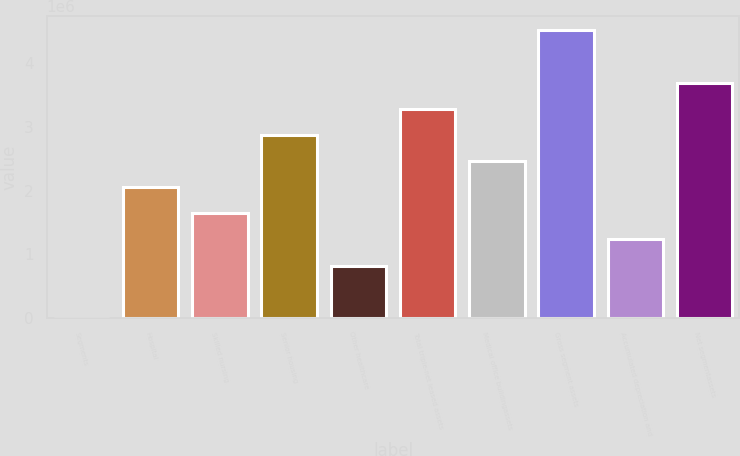Convert chart to OTSL. <chart><loc_0><loc_0><loc_500><loc_500><bar_chart><fcel>Segments<fcel>Hospital<fcel>Skilled nursing<fcel>Senior housing<fcel>Other healthcare<fcel>Total triple-net leased assets<fcel>Medical office buildingassets<fcel>Gross segment assets<fcel>Accumulated depreciation and<fcel>Net segmentassets<nl><fcel>2005<fcel>2.05484e+06<fcel>1.64427e+06<fcel>2.87598e+06<fcel>823140<fcel>3.28654e+06<fcel>2.46541e+06<fcel>4.51825e+06<fcel>1.23371e+06<fcel>3.69711e+06<nl></chart> 